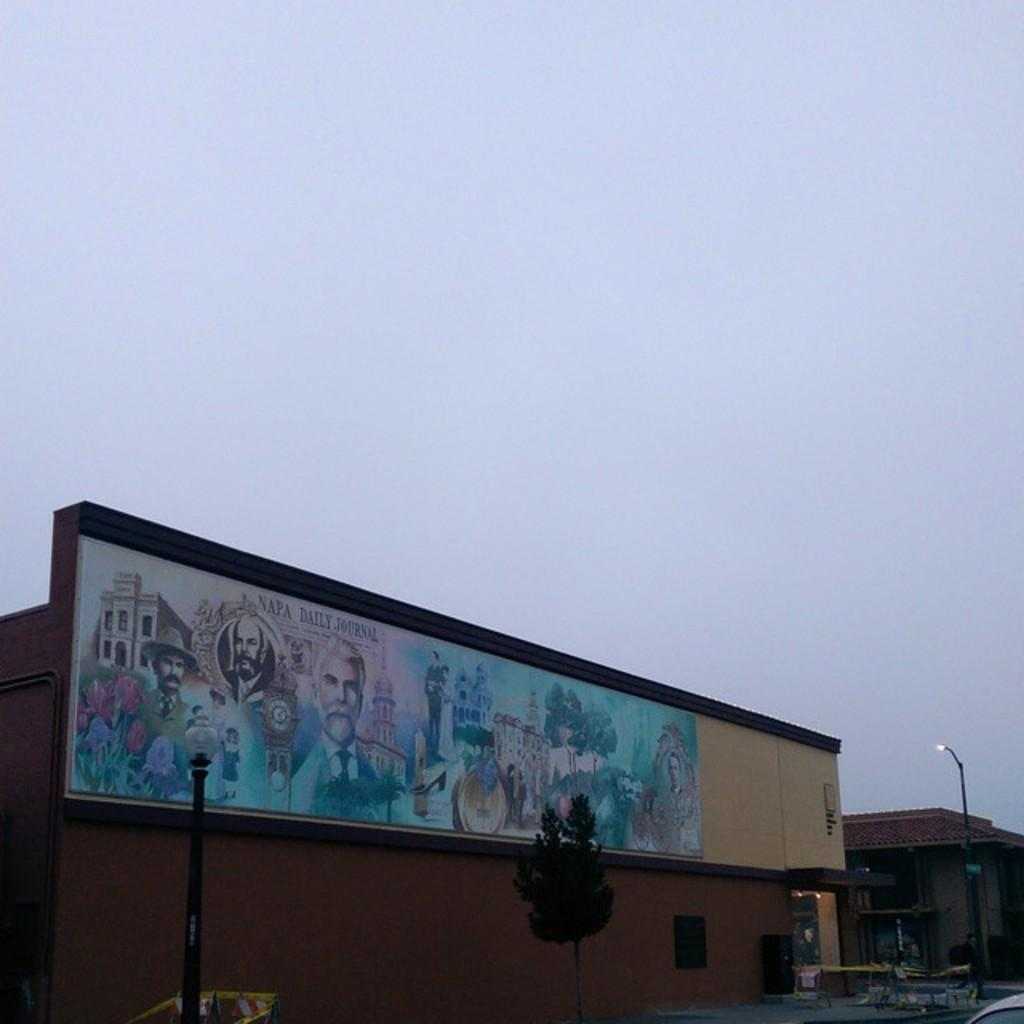<image>
Summarize the visual content of the image. A mural done by or for the Napa Daily journal. 